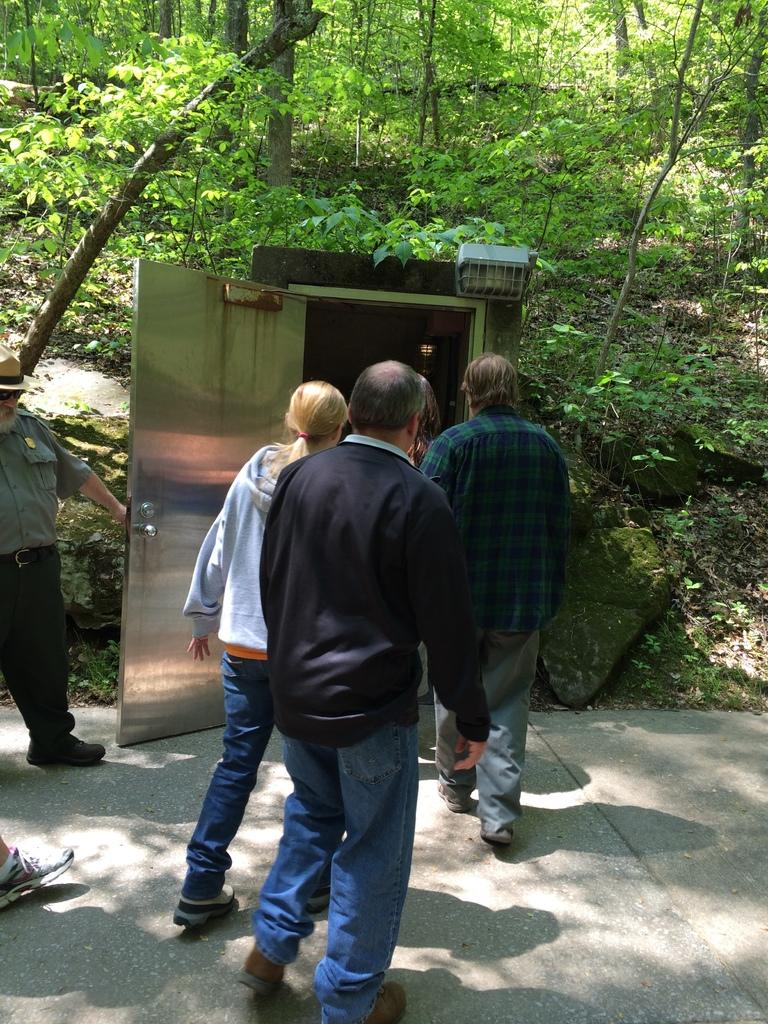What are the people in the image doing? The people in the image are walking on a road. What can be seen in the background of the image? There is a room and trees visible in the background. Can you hear the people laughing in the image? There is no sound in the image, so it is not possible to hear the people laughing. 